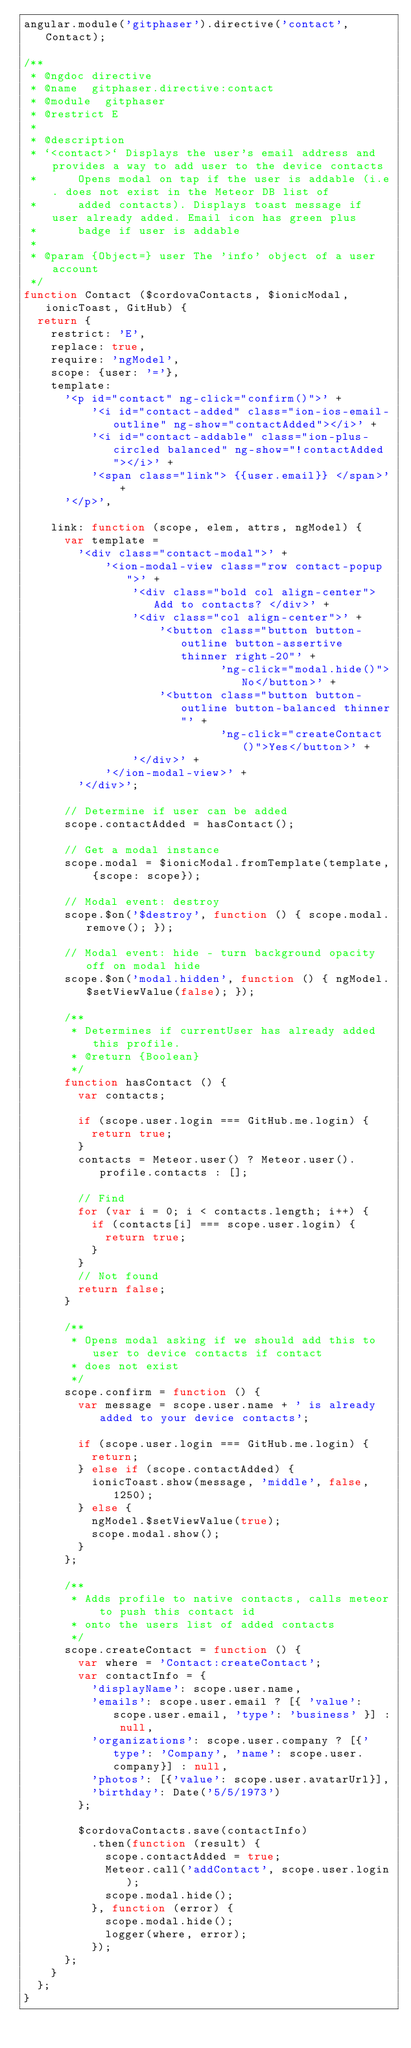<code> <loc_0><loc_0><loc_500><loc_500><_JavaScript_>angular.module('gitphaser').directive('contact', Contact);

/**
 * @ngdoc directive
 * @name  gitphaser.directive:contact
 * @module  gitphaser
 * @restrict E
 *
 * @description
 * `<contact>` Displays the user's email address and provides a way to add user to the device contacts
 *      Opens modal on tap if the user is addable (i.e. does not exist in the Meteor DB list of
 *      added contacts). Displays toast message if user already added. Email icon has green plus
 *      badge if user is addable
 *
 * @param {Object=} user The 'info' object of a user account
 */
function Contact ($cordovaContacts, $ionicModal, ionicToast, GitHub) {
  return {
    restrict: 'E',
    replace: true,
    require: 'ngModel',
    scope: {user: '='},
    template:
      '<p id="contact" ng-click="confirm()">' +
          '<i id="contact-added" class="ion-ios-email-outline" ng-show="contactAdded"></i>' +
          '<i id="contact-addable" class="ion-plus-circled balanced" ng-show="!contactAdded"></i>' +
          '<span class="link"> {{user.email}} </span>' +
      '</p>',

    link: function (scope, elem, attrs, ngModel) {
      var template =
        '<div class="contact-modal">' +
            '<ion-modal-view class="row contact-popup">' +
                '<div class="bold col align-center"> Add to contacts? </div>' +
                '<div class="col align-center">' +
                    '<button class="button button-outline button-assertive thinner right-20"' +
                             'ng-click="modal.hide()">No</button>' +
                    '<button class="button button-outline button-balanced thinner"' +
                             'ng-click="createContact()">Yes</button>' +
                '</div>' +
            '</ion-modal-view>' +
        '</div>';

      // Determine if user can be added
      scope.contactAdded = hasContact();

      // Get a modal instance
      scope.modal = $ionicModal.fromTemplate(template, {scope: scope});

      // Modal event: destroy
      scope.$on('$destroy', function () { scope.modal.remove(); });

      // Modal event: hide - turn background opacity off on modal hide
      scope.$on('modal.hidden', function () { ngModel.$setViewValue(false); });
      
      /**
       * Determines if currentUser has already added this profile.
       * @return {Boolean}
       */
      function hasContact () {
        var contacts;

        if (scope.user.login === GitHub.me.login) {
          return true;
        }
        contacts = Meteor.user() ? Meteor.user().profile.contacts : [];

        // Find
        for (var i = 0; i < contacts.length; i++) {
          if (contacts[i] === scope.user.login) {
            return true;
          }
        }
        // Not found
        return false;
      }

      /**
       * Opens modal asking if we should add this to user to device contacts if contact
       * does not exist
       */
      scope.confirm = function () {
        var message = scope.user.name + ' is already added to your device contacts';

        if (scope.user.login === GitHub.me.login) {
          return;
        } else if (scope.contactAdded) {
          ionicToast.show(message, 'middle', false, 1250);
        } else {
          ngModel.$setViewValue(true);
          scope.modal.show();
        }
      };

      /**
       * Adds profile to native contacts, calls meteor to push this contact id
       * onto the users list of added contacts
       */
      scope.createContact = function () {
        var where = 'Contact:createContact';
        var contactInfo = {
          'displayName': scope.user.name,
          'emails': scope.user.email ? [{ 'value': scope.user.email, 'type': 'business' }] : null,
          'organizations': scope.user.company ? [{'type': 'Company', 'name': scope.user.company}] : null,
          'photos': [{'value': scope.user.avatarUrl}],
          'birthday': Date('5/5/1973')
        };

        $cordovaContacts.save(contactInfo)
          .then(function (result) {
            scope.contactAdded = true;
            Meteor.call('addContact', scope.user.login);
            scope.modal.hide();
          }, function (error) {
            scope.modal.hide();
            logger(where, error);
          });
      };
    }
  };
}
</code> 